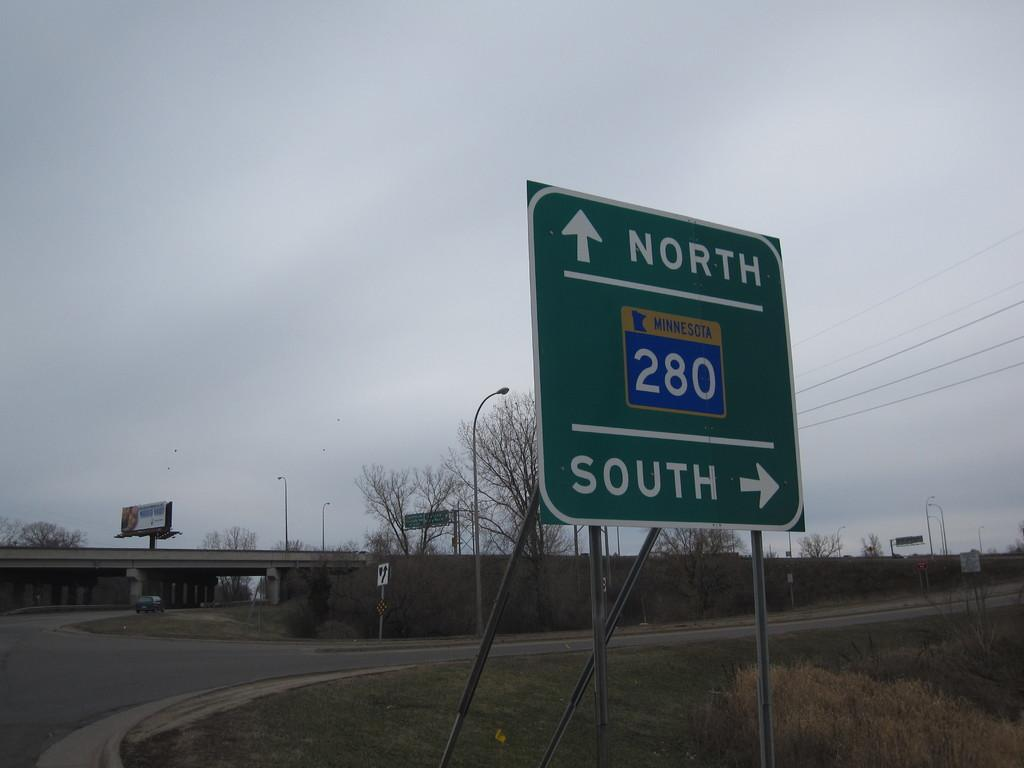<image>
Summarize the visual content of the image. A street sign for Minnesota 280 directing them to onramps that are north and southbound 